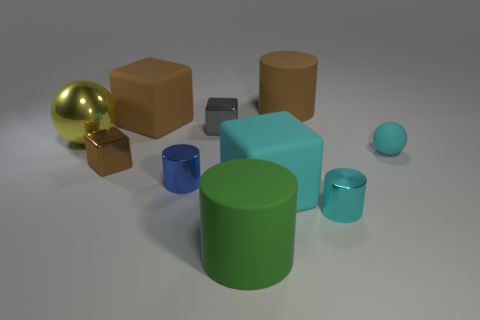Subtract all big brown cubes. How many cubes are left? 3 Subtract 1 cylinders. How many cylinders are left? 3 Subtract all red spheres. How many brown blocks are left? 2 Subtract all blue cylinders. How many cylinders are left? 3 Subtract all cylinders. How many objects are left? 6 Add 6 big brown rubber things. How many big brown rubber things are left? 8 Add 5 small cyan rubber spheres. How many small cyan rubber spheres exist? 6 Subtract 0 brown balls. How many objects are left? 10 Subtract all green balls. Subtract all brown cylinders. How many balls are left? 2 Subtract all small matte cylinders. Subtract all small rubber objects. How many objects are left? 9 